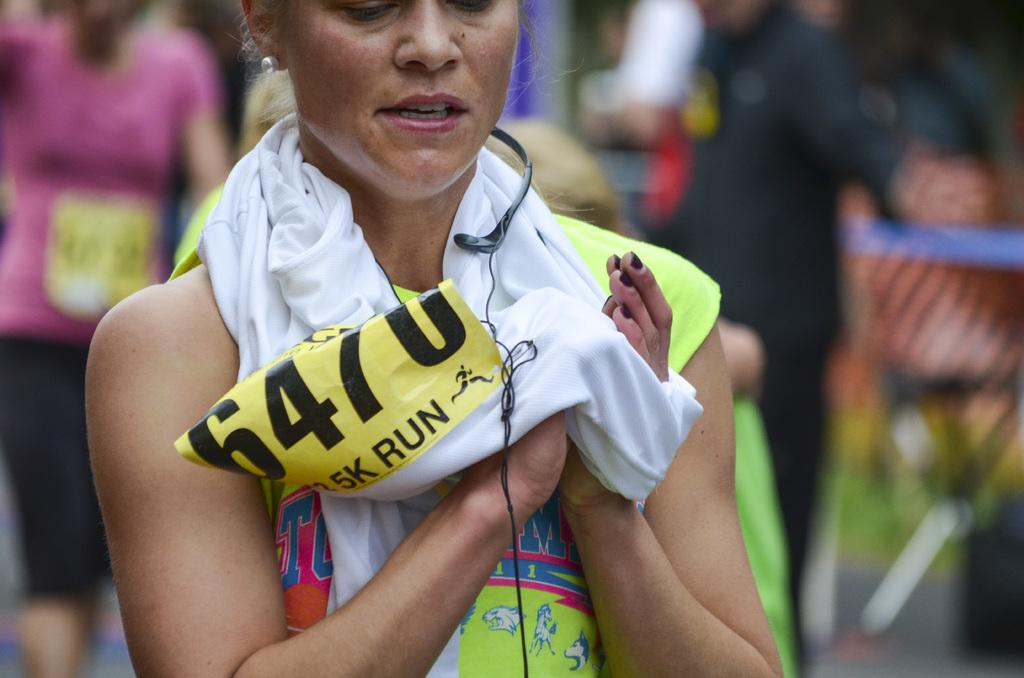<image>
Create a compact narrative representing the image presented. a woman clasping her hands after a 5k run 